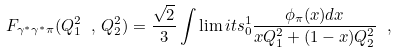<formula> <loc_0><loc_0><loc_500><loc_500>F _ { \gamma ^ { * } \gamma ^ { * } \pi } ( Q _ { 1 } ^ { 2 } \ , \, Q _ { 2 } ^ { 2 } ) = \frac { \sqrt { 2 } } { 3 } \int \lim i t s _ { 0 } ^ { 1 } \frac { \phi _ { \pi } ( x ) d x } { x Q _ { 1 } ^ { 2 } + ( 1 - x ) Q _ { 2 } ^ { 2 } } \ ,</formula> 